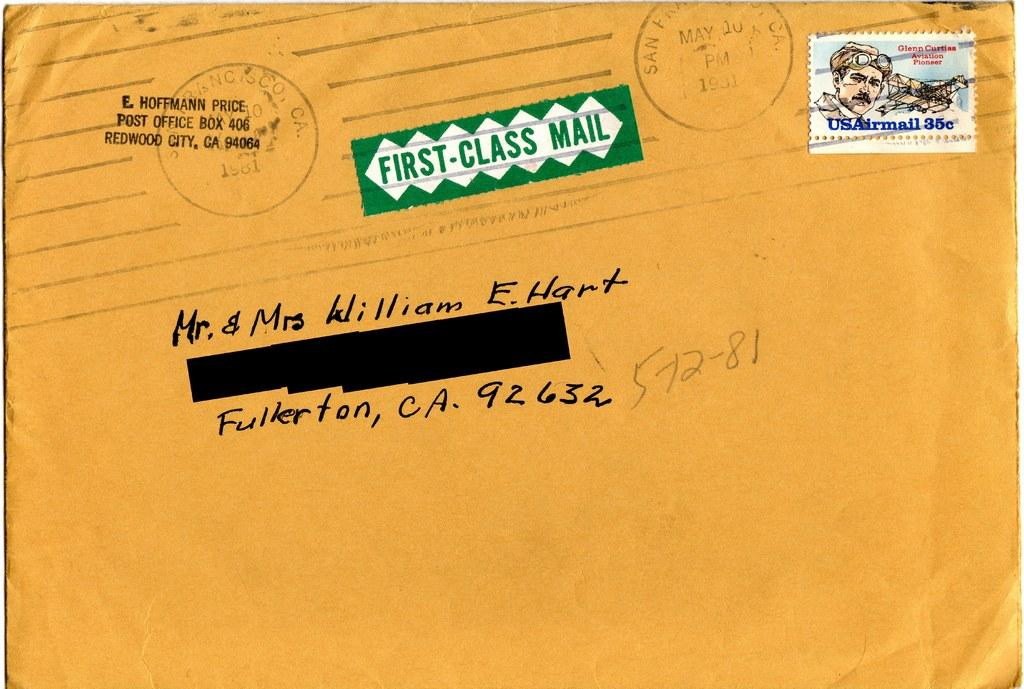<image>
Render a clear and concise summary of the photo. A letter addressed to Mr. and Mrs. William E. Hart. 